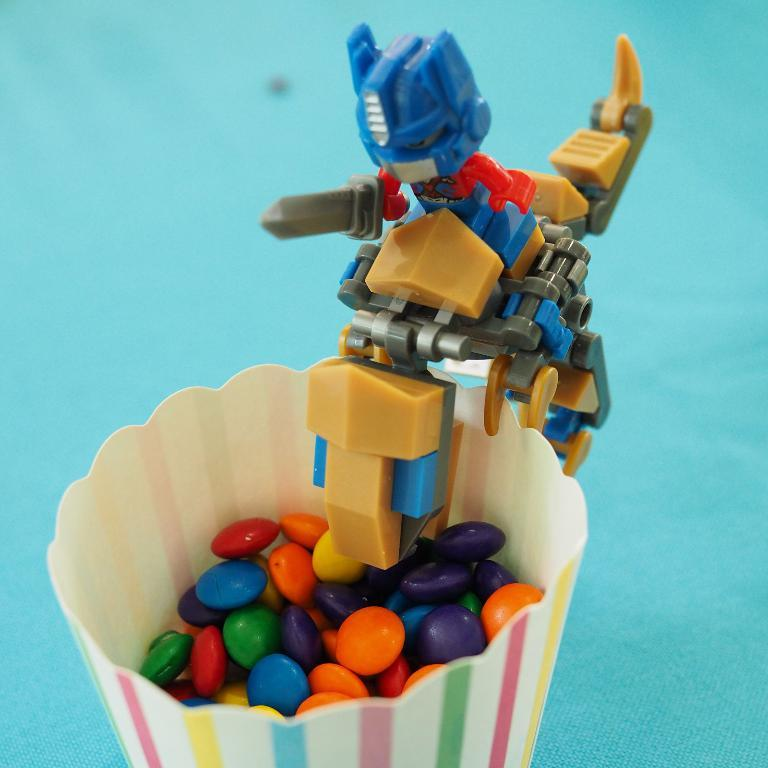What is in the glass that is visible in the image? The glass contains colorful chocolates. Where are the chocolates located in the glass? The chocolates are visible at the bottom of the glass. What object is in front of the glass in the image? There is a toy robot in front of the glass. What is the background color of the image? The background color of the image is sky. What type of alarm can be heard going off in the image? There is no alarm present in the image, so it is not possible to hear any alarm sounds. 